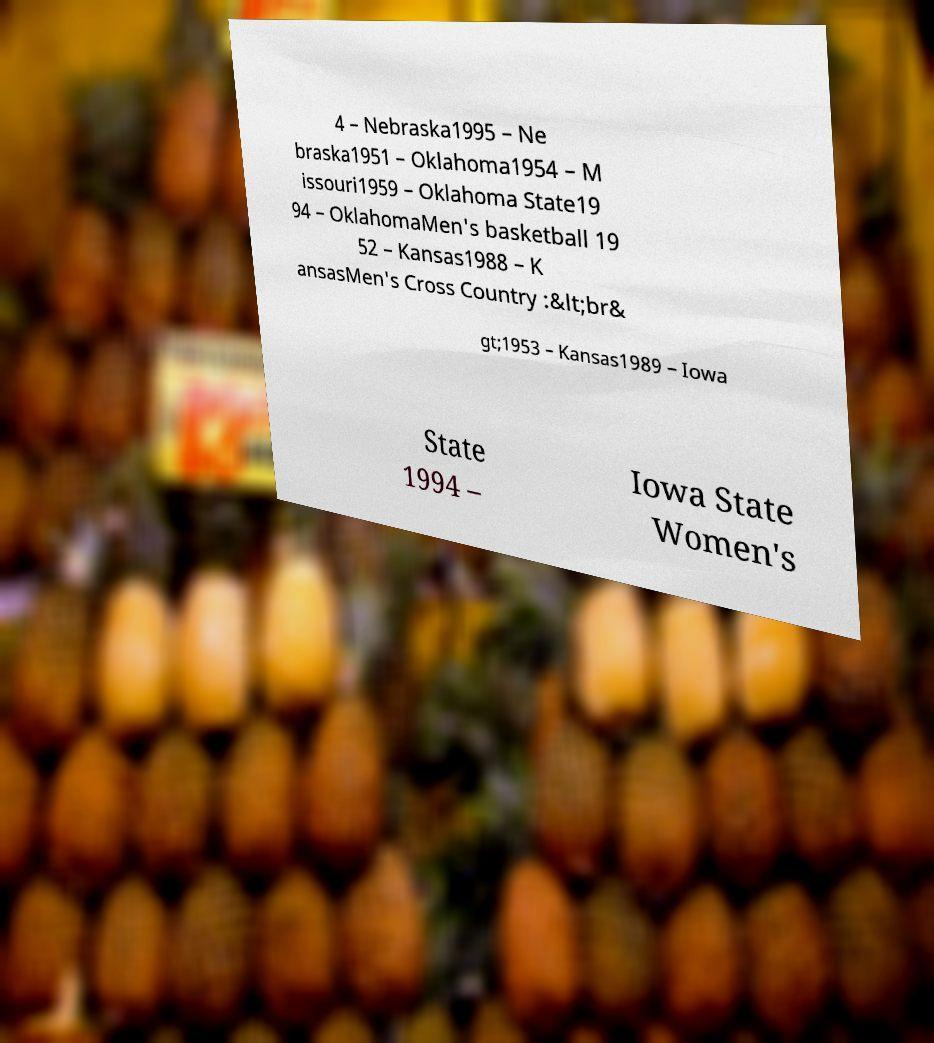I need the written content from this picture converted into text. Can you do that? 4 – Nebraska1995 – Ne braska1951 – Oklahoma1954 – M issouri1959 – Oklahoma State19 94 – OklahomaMen's basketball 19 52 – Kansas1988 – K ansasMen's Cross Country :&lt;br& gt;1953 – Kansas1989 – Iowa State 1994 – Iowa State Women's 